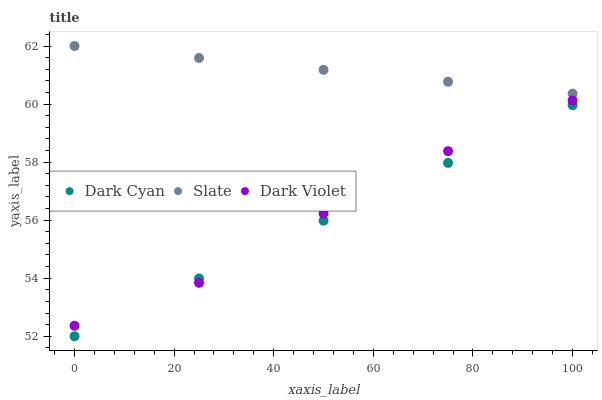Does Dark Cyan have the minimum area under the curve?
Answer yes or no. Yes. Does Slate have the maximum area under the curve?
Answer yes or no. Yes. Does Dark Violet have the minimum area under the curve?
Answer yes or no. No. Does Dark Violet have the maximum area under the curve?
Answer yes or no. No. Is Dark Cyan the smoothest?
Answer yes or no. Yes. Is Dark Violet the roughest?
Answer yes or no. Yes. Is Slate the smoothest?
Answer yes or no. No. Is Slate the roughest?
Answer yes or no. No. Does Dark Cyan have the lowest value?
Answer yes or no. Yes. Does Dark Violet have the lowest value?
Answer yes or no. No. Does Slate have the highest value?
Answer yes or no. Yes. Does Dark Violet have the highest value?
Answer yes or no. No. Is Dark Violet less than Slate?
Answer yes or no. Yes. Is Slate greater than Dark Violet?
Answer yes or no. Yes. Does Dark Cyan intersect Dark Violet?
Answer yes or no. Yes. Is Dark Cyan less than Dark Violet?
Answer yes or no. No. Is Dark Cyan greater than Dark Violet?
Answer yes or no. No. Does Dark Violet intersect Slate?
Answer yes or no. No. 